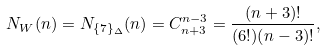Convert formula to latex. <formula><loc_0><loc_0><loc_500><loc_500>N _ { W } ( n ) = N _ { \{ 7 \} _ { \Delta } } ( n ) = C _ { n + 3 } ^ { n - 3 } = \frac { ( n + 3 ) ! } { ( 6 ! ) ( n - 3 ) ! } ,</formula> 